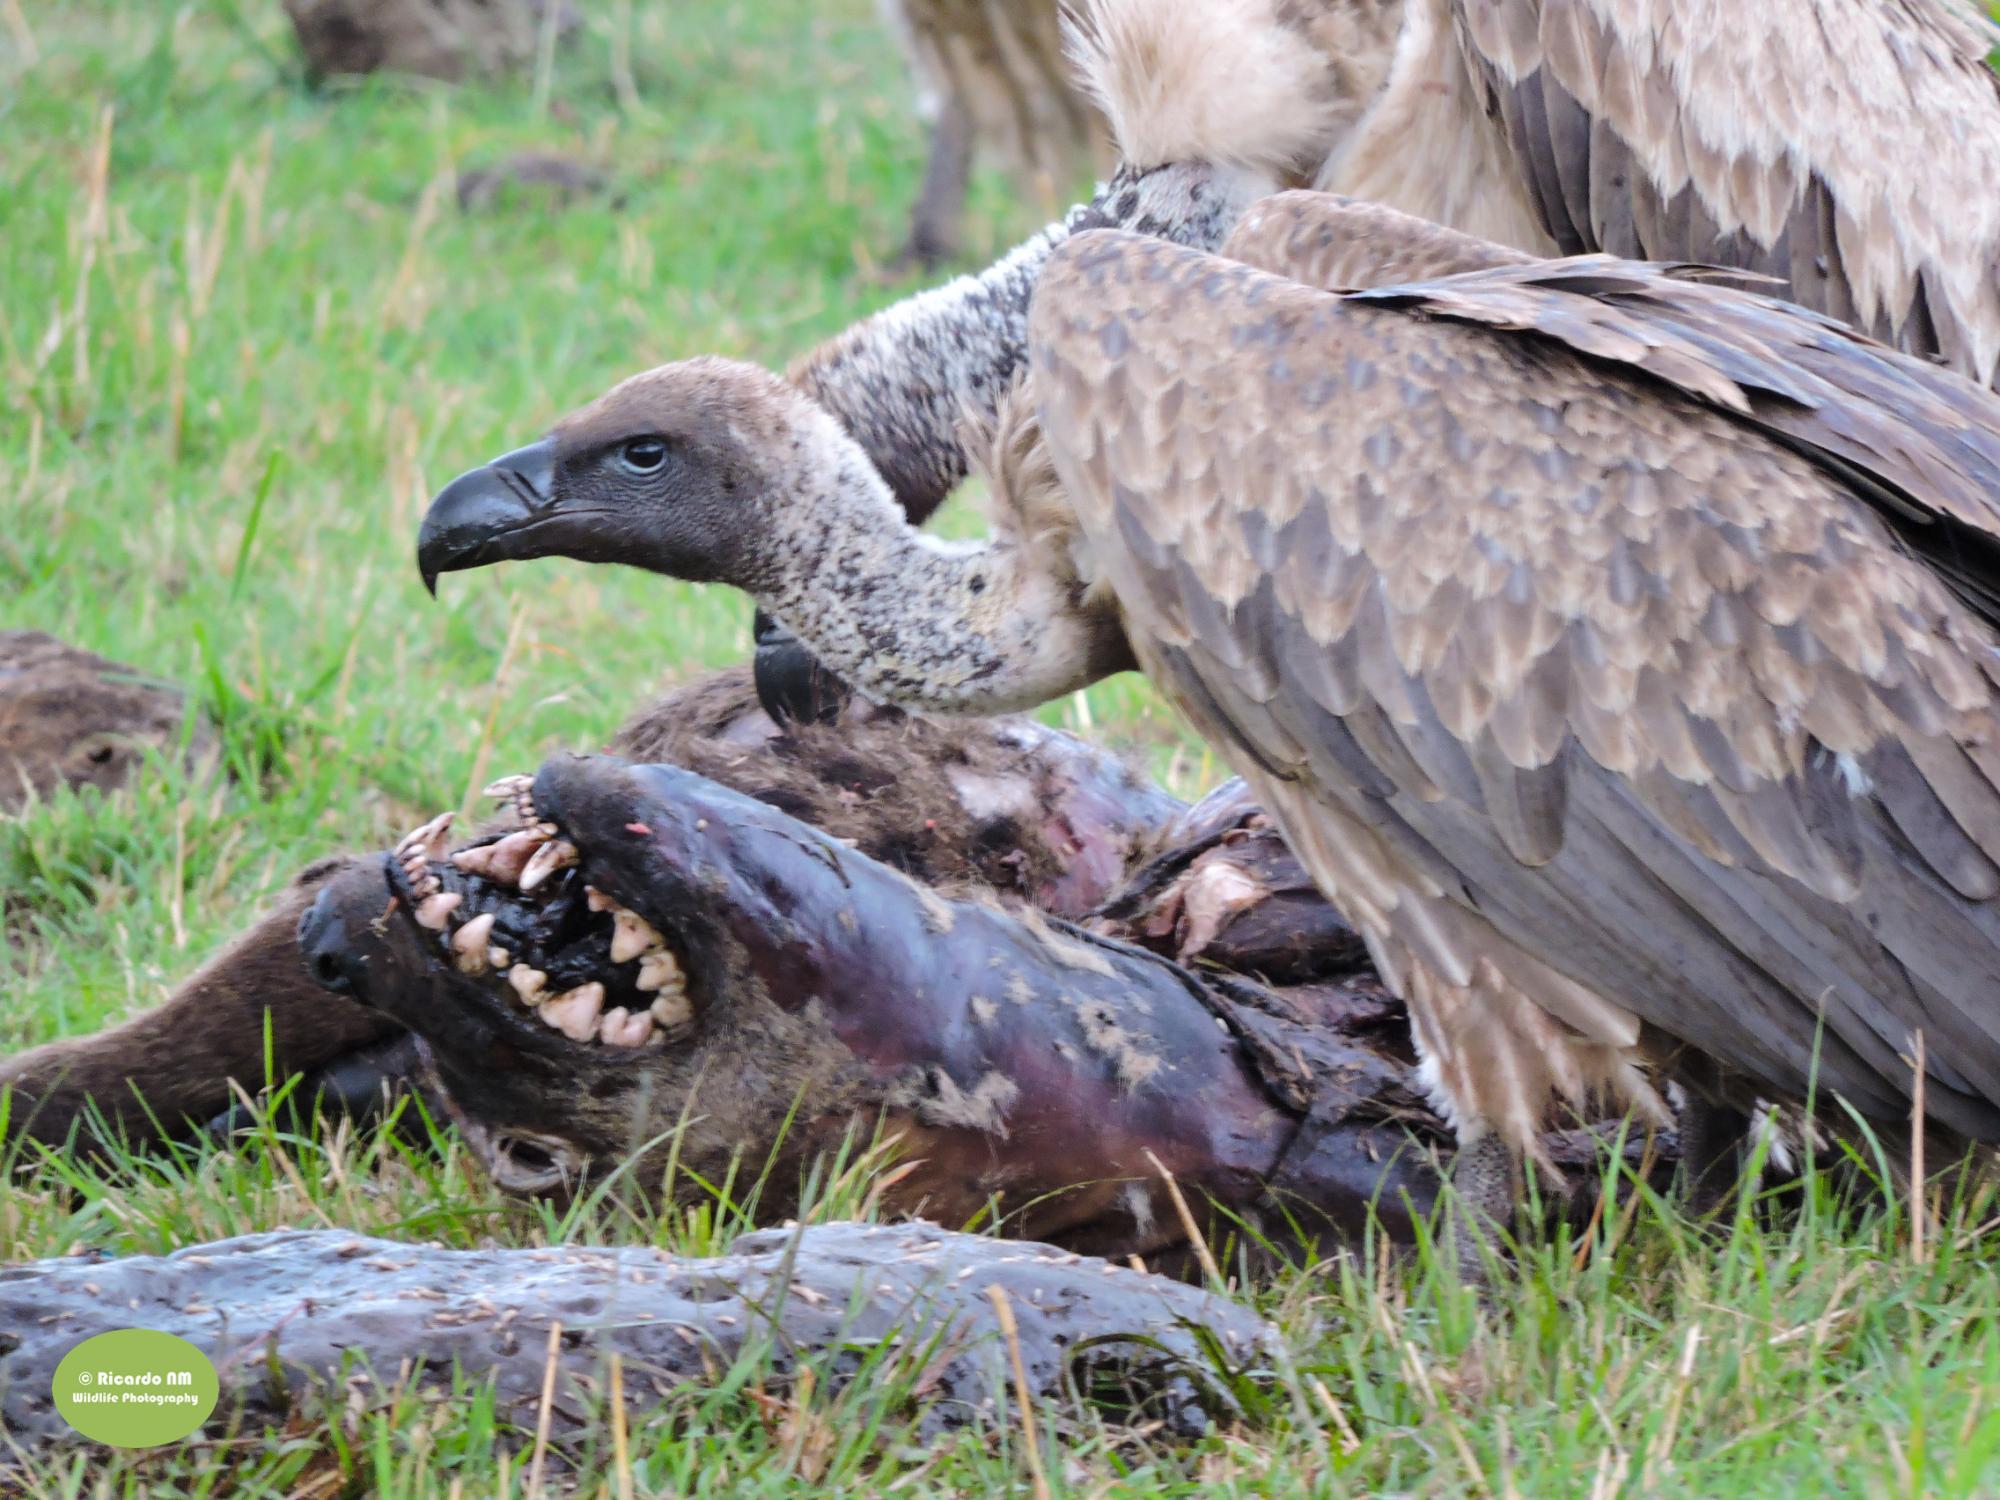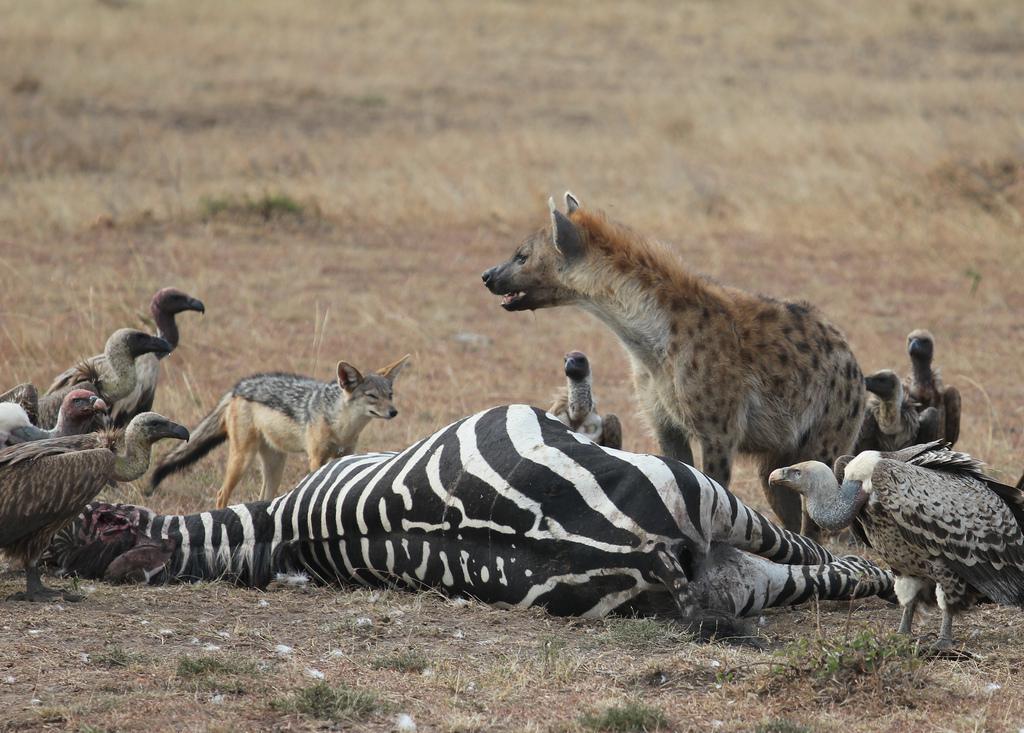The first image is the image on the left, the second image is the image on the right. Given the left and right images, does the statement "In one of the images, the animals are obviously feasting on zebra." hold true? Answer yes or no. Yes. The first image is the image on the left, the second image is the image on the right. For the images displayed, is the sentence "There are at least five vultures and one hyena facing out on a did zebra" factually correct? Answer yes or no. Yes. 